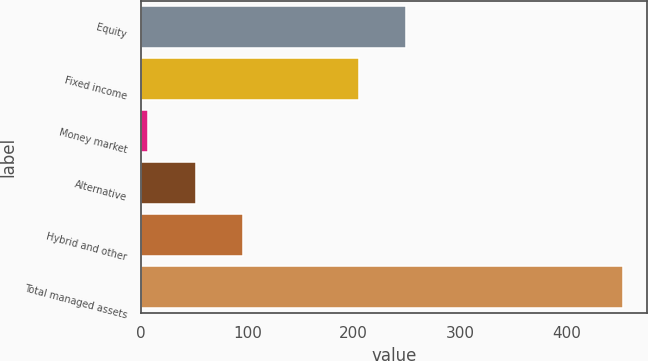Convert chart. <chart><loc_0><loc_0><loc_500><loc_500><bar_chart><fcel>Equity<fcel>Fixed income<fcel>Money market<fcel>Alternative<fcel>Hybrid and other<fcel>Total managed assets<nl><fcel>249.53<fcel>204.9<fcel>7<fcel>51.63<fcel>96.26<fcel>453.3<nl></chart> 